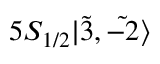Convert formula to latex. <formula><loc_0><loc_0><loc_500><loc_500>5 S _ { 1 / 2 } | \tilde { 3 } , \tilde { - 2 } \rangle</formula> 